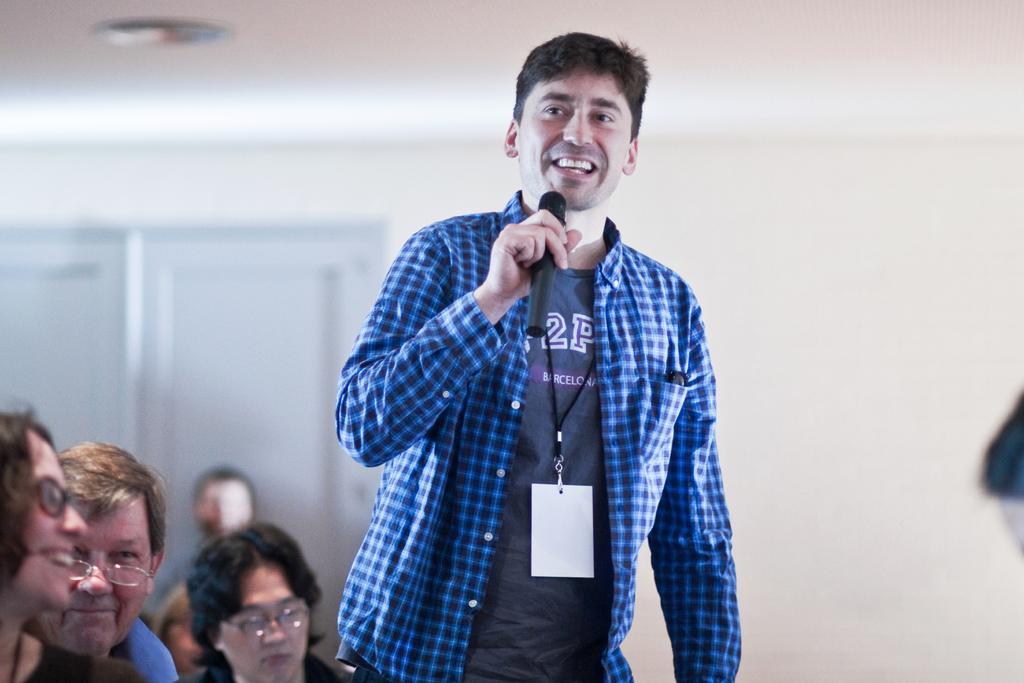In one or two sentences, can you explain what this image depicts? In Front portion of a picture we can see a man holding a mike in his hand and talking. He wore id card. At the left side of the picture we can see persons. This is a wall and a door. 